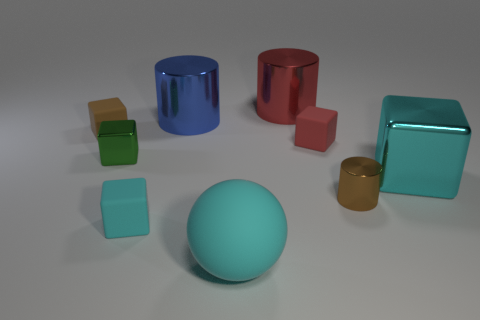Subtract all big cylinders. How many cylinders are left? 1 Subtract all green cubes. How many cubes are left? 4 Add 1 large blue cylinders. How many objects exist? 10 Subtract all yellow blocks. Subtract all green balls. How many blocks are left? 5 Subtract all spheres. How many objects are left? 8 Add 4 small gray matte cubes. How many small gray matte cubes exist? 4 Subtract 0 green spheres. How many objects are left? 9 Subtract all green metal things. Subtract all small matte cubes. How many objects are left? 5 Add 4 cyan metal things. How many cyan metal things are left? 5 